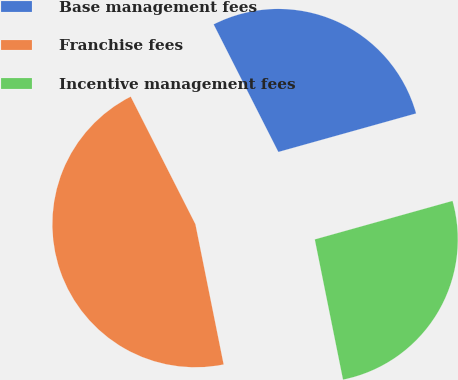<chart> <loc_0><loc_0><loc_500><loc_500><pie_chart><fcel>Base management fees<fcel>Franchise fees<fcel>Incentive management fees<nl><fcel>28.13%<fcel>45.69%<fcel>26.18%<nl></chart> 